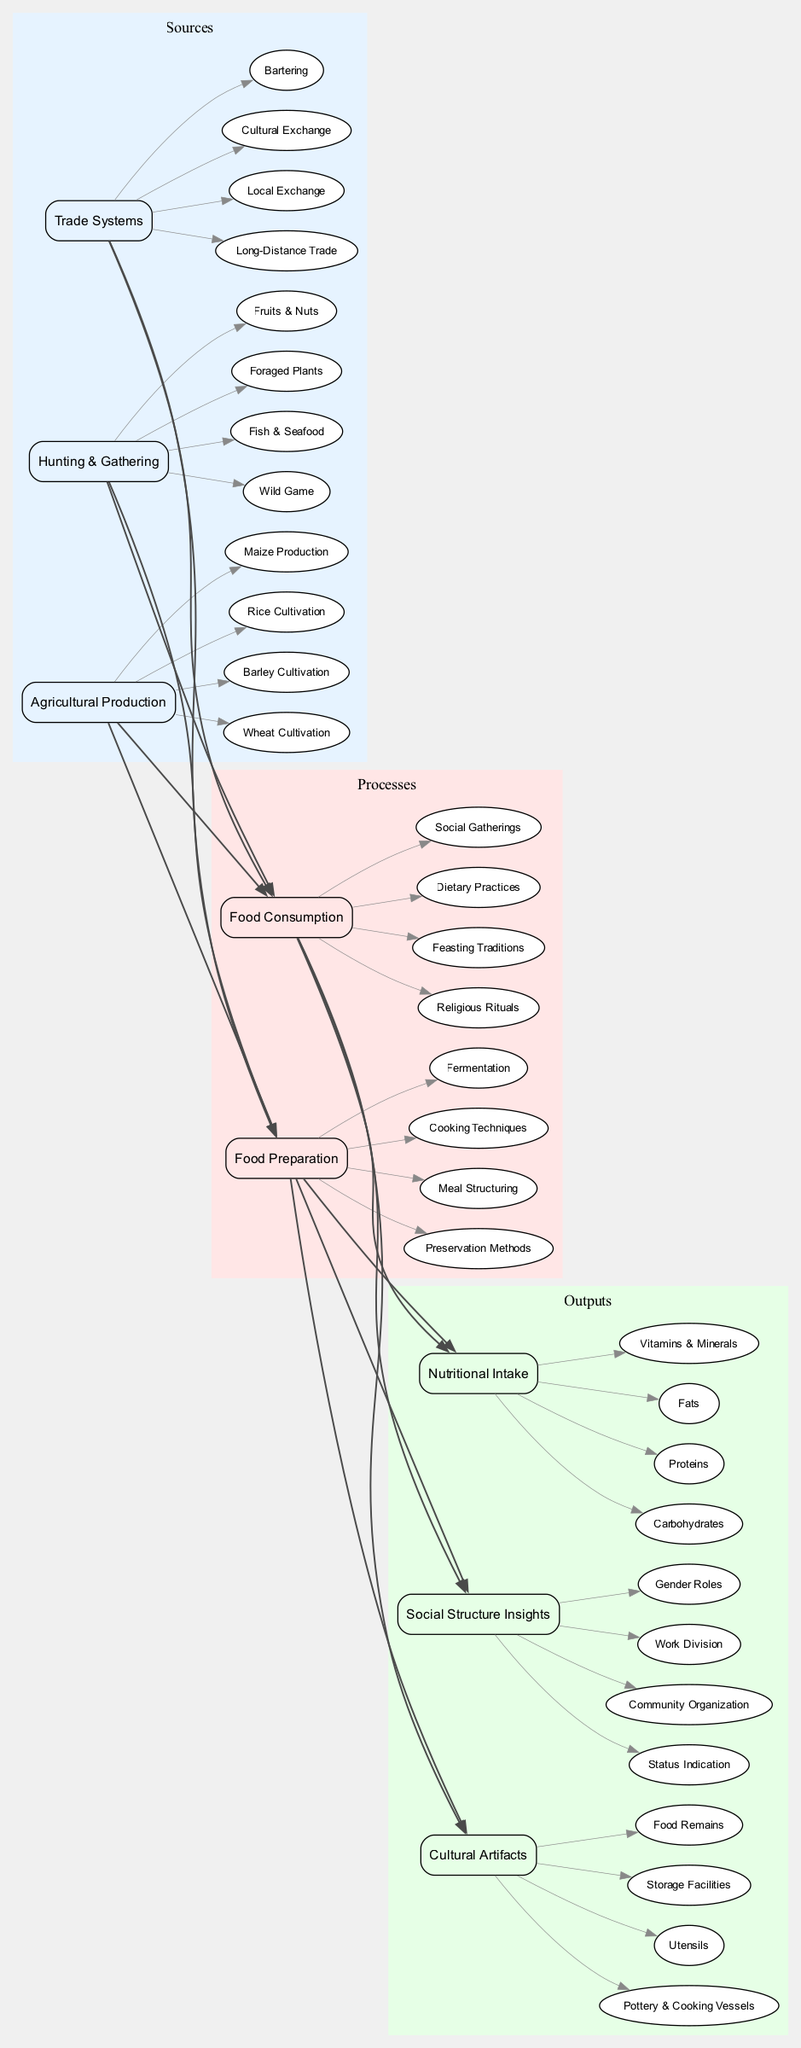What are the input categories in the diagram? The diagram has three input categories: Agricultural Production, Hunting & Gathering, and Trade Systems. These are listed at the leftmost side of the Sankey Diagram, representing where the food originates.
Answer: Agricultural Production, Hunting & Gathering, Trade Systems How many subcategories are under Food Consumption? The Food Consumption process has four subcategories: Dietary Practices, Social Gatherings, Religious Rituals, and Feasting Traditions. These can be found connected to the Food Consumption node in the diagram.
Answer: 4 What type of output is associated with Cultural Artifacts? Cultural Artifacts are associated with the output category and are illustrated by four specific subcategories: Pottery & Cooking Vessels, Utensils, Storage Facilities, and Food Remains. This relationship is shown by the edges flowing from the Cultural Artifacts node.
Answer: Pottery & Cooking Vessels, Utensils, Storage Facilities, Food Remains Which input category provides the most diverse sources? Hunting & Gathering consists of four diverse sources: Wild Game, Fish & Seafood, Foraged Plants, and Fruits & Nuts, making it the input category with the most diverse sources. This can be inferred from comparing the number of subcategories in the input categories.
Answer: Hunting & Gathering What relationships exist between Food Preparation and Nutritional Intake? Food Preparation connects directly to Nutritional Intake through the Food Consumption process. It indicates that the methods of food preparation directly affect what types of nutrients are consumed. This logical flow can be followed through the edges connecting these nodes in the diagram.
Answer: Cooking Techniques, Fermentation, Preservation Methods, Meal Structuring How many main processes are presented in the diagram? The diagram presents two main processes: Food Preparation and Food Consumption. This can be observed in the central part of the diagram where the processes are shown clearly.
Answer: 2 What is the significance of the edges in the Sankey Diagram? The edges represent the flow of food consumption patterns from sources through processes to outputs, indicating how food intake and related activities are interconnected. The thickness of the edges often denotes the significance or volume of flow.
Answer: Flow of food consumption patterns Which output suggests insights about societal roles? Social Structure Insights provide insights about societal roles such as Status Indication, Community Organization, Work Division, and Gender Roles, pointing to the relationships among food practices and social structures.
Answer: Social Structure Insights 